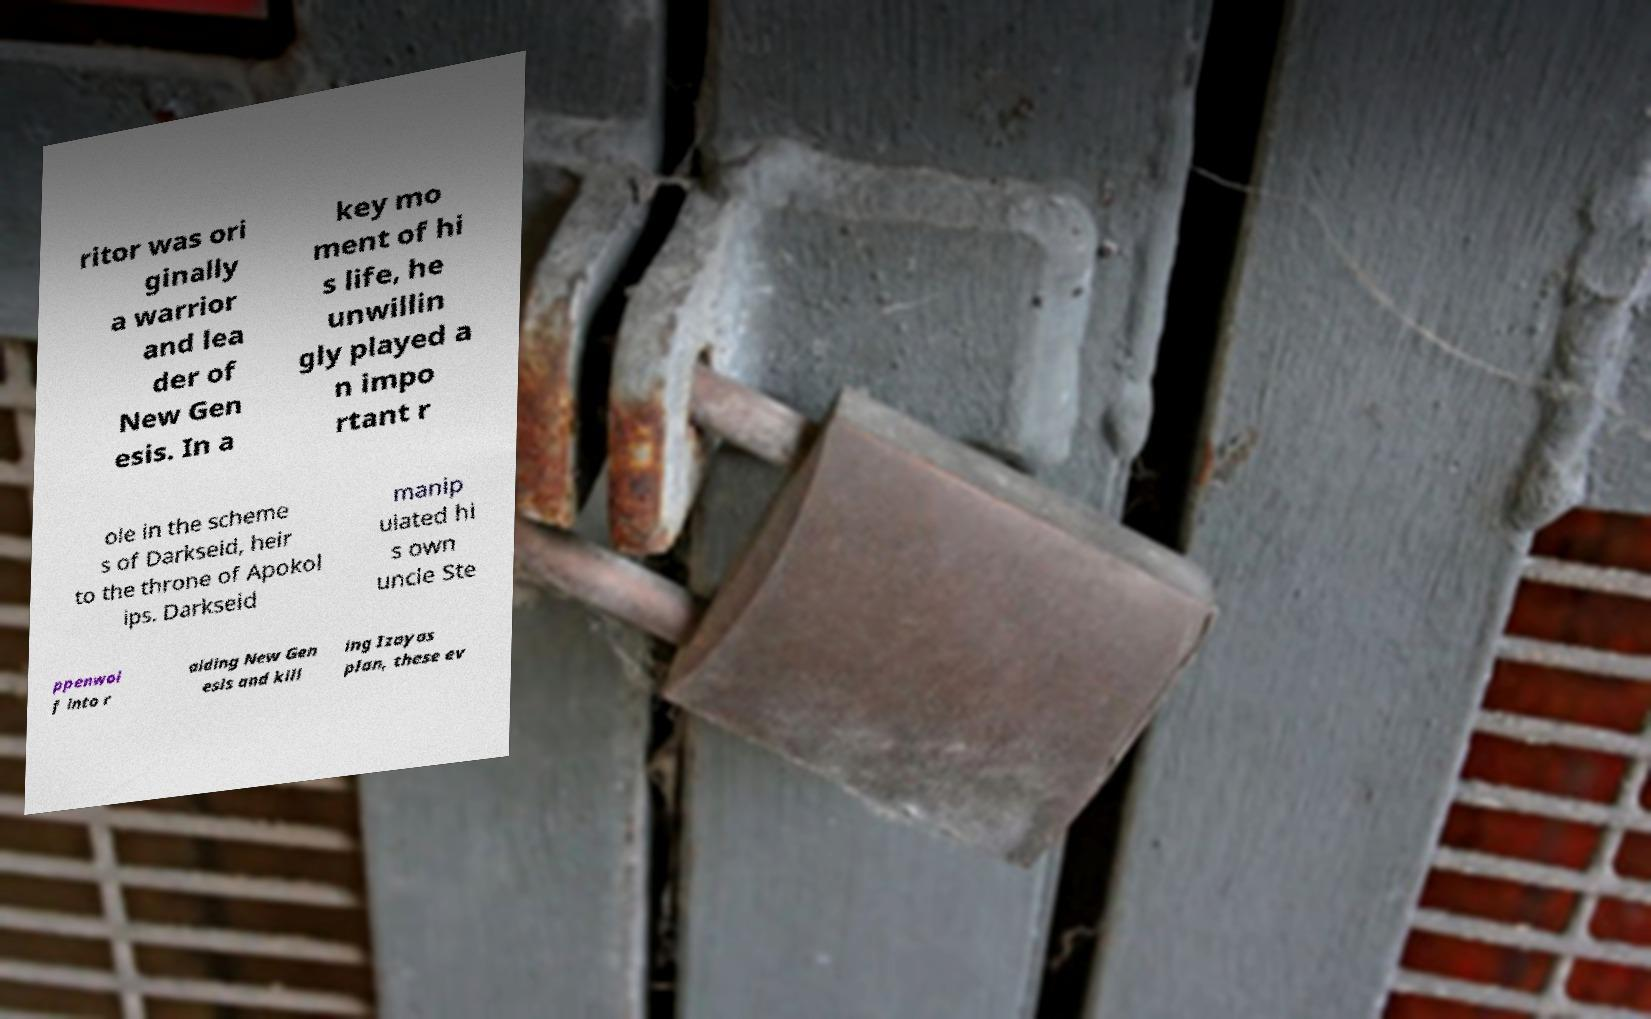For documentation purposes, I need the text within this image transcribed. Could you provide that? ritor was ori ginally a warrior and lea der of New Gen esis. In a key mo ment of hi s life, he unwillin gly played a n impo rtant r ole in the scheme s of Darkseid, heir to the throne of Apokol ips. Darkseid manip ulated hi s own uncle Ste ppenwol f into r aiding New Gen esis and kill ing Izayas plan, these ev 